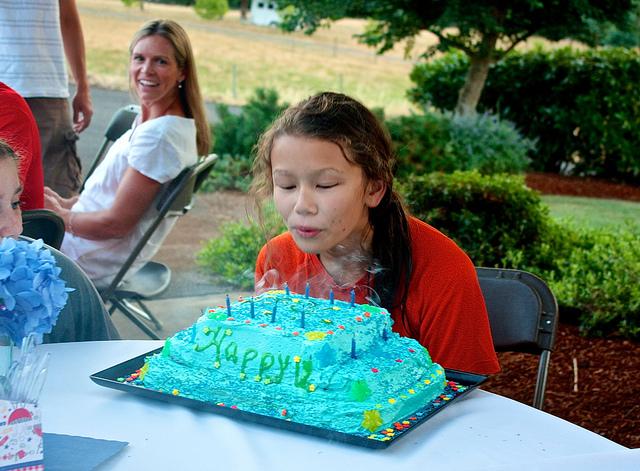What color is the border of the cake?
Write a very short answer. Blue. Do the chairs fold up?
Short answer required. Yes. Is this the gold anniversary?
Give a very brief answer. No. How old is the girl blowing out the candles?
Write a very short answer. 12. Who is on the cake?
Answer briefly. Girl. How many candles are on the cake?
Be succinct. 10. What number is on the cake?
Give a very brief answer. 12. Is the frosting blue?
Be succinct. Yes. 